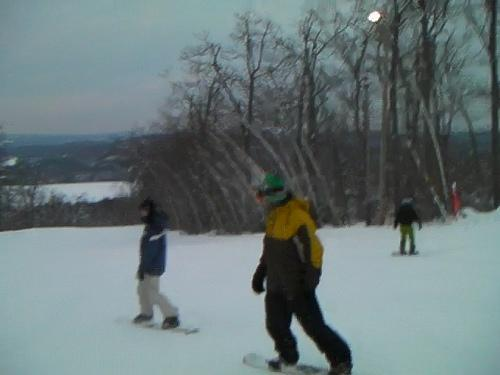Where does the white light come from? Please explain your reasoning. lamp. There is a round celestial body in the sky. 